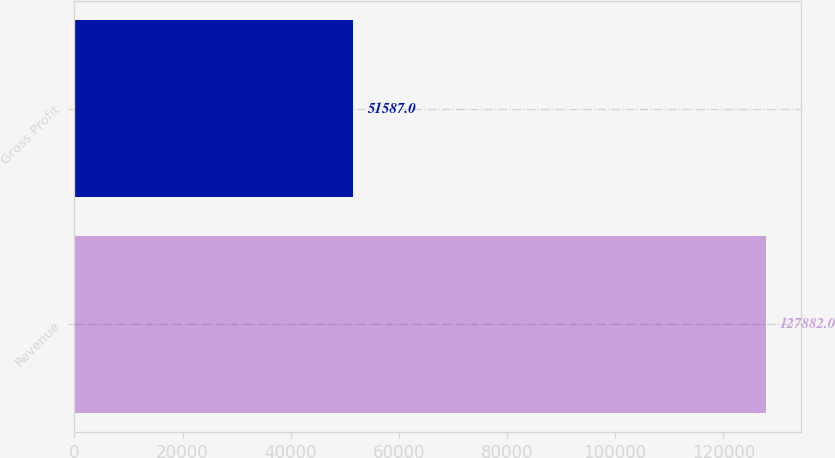Convert chart to OTSL. <chart><loc_0><loc_0><loc_500><loc_500><bar_chart><fcel>Revenue<fcel>Gross Profit<nl><fcel>127882<fcel>51587<nl></chart> 